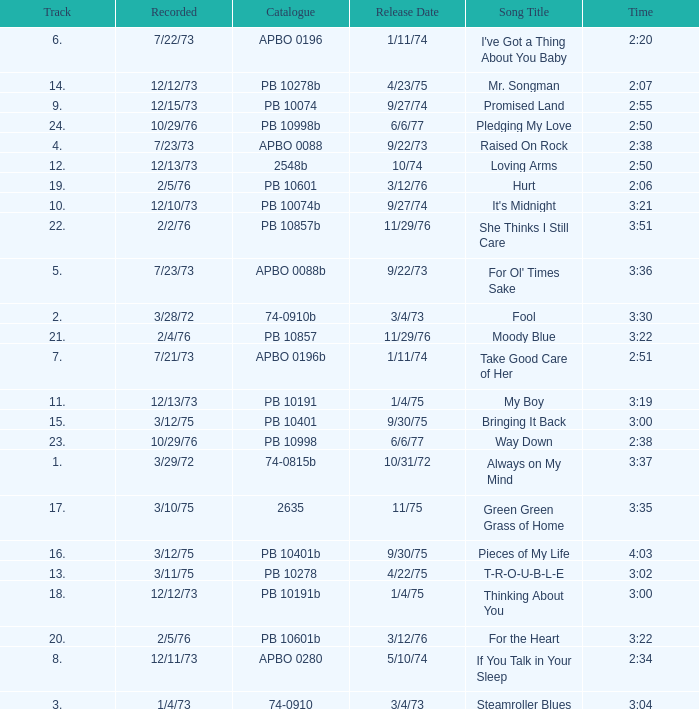Name the catalogue that has tracks less than 13 and the release date of 10/31/72 74-0815b. 